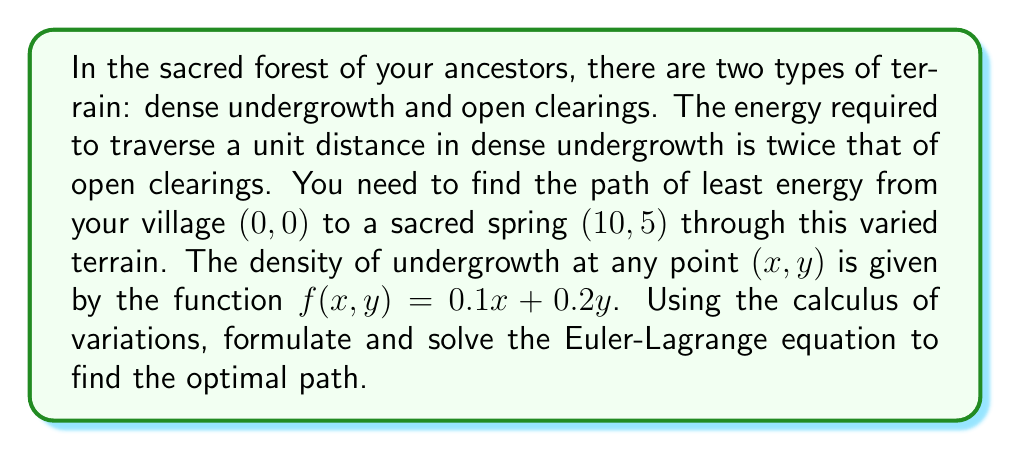Give your solution to this math problem. 1. First, we need to formulate the energy functional. The energy required to traverse a small distance ds is proportional to (1 + f(x,y))ds. The total energy along a path y(x) is:

   $$E[y] = \int_0^{10} (1 + 0.1x + 0.2y) \sqrt{1 + (y')^2} dx$$

2. The Euler-Lagrange equation for this functional is:

   $$\frac{\partial F}{\partial y} - \frac{d}{dx}\left(\frac{\partial F}{\partial y'}\right) = 0$$

   where $F = (1 + 0.1x + 0.2y) \sqrt{1 + (y')^2}$

3. Calculating the partial derivatives:

   $$\frac{\partial F}{\partial y} = 0.2 \sqrt{1 + (y')^2}$$
   $$\frac{\partial F}{\partial y'} = (1 + 0.1x + 0.2y) \frac{y'}{\sqrt{1 + (y')^2}}$$

4. Substituting into the Euler-Lagrange equation:

   $$0.2 \sqrt{1 + (y')^2} - \frac{d}{dx}\left((1 + 0.1x + 0.2y) \frac{y'}{\sqrt{1 + (y')^2}}\right) = 0$$

5. This differential equation is complex and doesn't have a simple analytical solution. However, we can approximate the solution numerically using the following observations:

   - The path will curve away from areas of high undergrowth density.
   - It will tend to be straighter in areas of low density.
   - The overall path will be a smooth curve due to the nature of the variational problem.

6. A reasonable approximation of the optimal path would be a parabolic curve:

   $$y(x) = ax^2 + bx$$

   where a and b are constants to be determined.

7. Given the boundary conditions y(0) = 0 and y(10) = 5, we can solve for a and b:

   $$0 = a(0)^2 + b(0)$$
   $$5 = a(10)^2 + b(10)$$

   Solving this system gives us $a = -0.025$ and $b = 0.75$

8. Therefore, an approximate optimal path is:

   $$y(x) = -0.025x^2 + 0.75x$$

This path curves slightly upward initially to avoid the increasing undergrowth density, then curves back down to reach the destination.
Answer: $y(x) = -0.025x^2 + 0.75x$ 